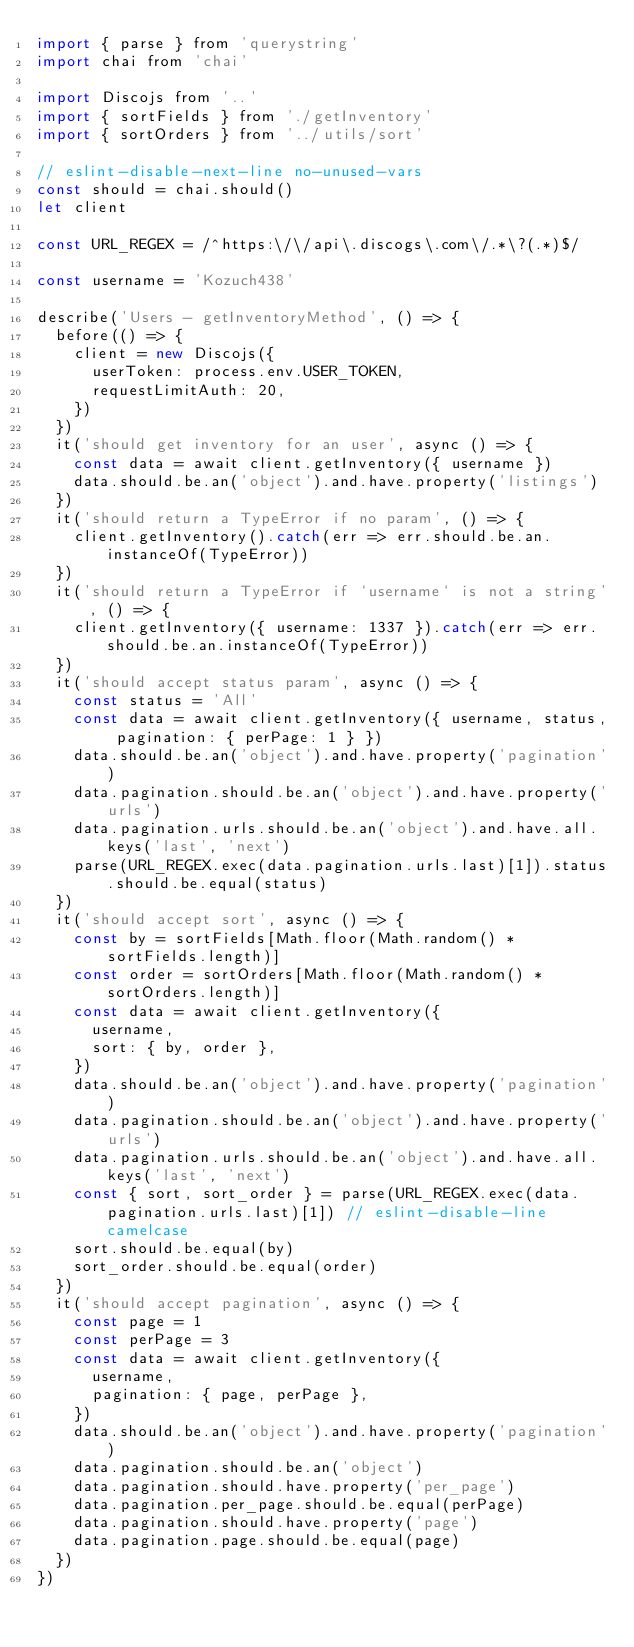Convert code to text. <code><loc_0><loc_0><loc_500><loc_500><_JavaScript_>import { parse } from 'querystring'
import chai from 'chai'

import Discojs from '..'
import { sortFields } from './getInventory'
import { sortOrders } from '../utils/sort'

// eslint-disable-next-line no-unused-vars
const should = chai.should()
let client

const URL_REGEX = /^https:\/\/api\.discogs\.com\/.*\?(.*)$/

const username = 'Kozuch438'

describe('Users - getInventoryMethod', () => {
  before(() => {
    client = new Discojs({
      userToken: process.env.USER_TOKEN,
      requestLimitAuth: 20,
    })
  })
  it('should get inventory for an user', async () => {
    const data = await client.getInventory({ username })
    data.should.be.an('object').and.have.property('listings')
  })
  it('should return a TypeError if no param', () => {
    client.getInventory().catch(err => err.should.be.an.instanceOf(TypeError))
  })
  it('should return a TypeError if `username` is not a string', () => {
    client.getInventory({ username: 1337 }).catch(err => err.should.be.an.instanceOf(TypeError))
  })
  it('should accept status param', async () => {
    const status = 'All'
    const data = await client.getInventory({ username, status, pagination: { perPage: 1 } })
    data.should.be.an('object').and.have.property('pagination')
    data.pagination.should.be.an('object').and.have.property('urls')
    data.pagination.urls.should.be.an('object').and.have.all.keys('last', 'next')
    parse(URL_REGEX.exec(data.pagination.urls.last)[1]).status.should.be.equal(status)
  })
  it('should accept sort', async () => {
    const by = sortFields[Math.floor(Math.random() * sortFields.length)]
    const order = sortOrders[Math.floor(Math.random() * sortOrders.length)]
    const data = await client.getInventory({
      username,
      sort: { by, order },
    })
    data.should.be.an('object').and.have.property('pagination')
    data.pagination.should.be.an('object').and.have.property('urls')
    data.pagination.urls.should.be.an('object').and.have.all.keys('last', 'next')
    const { sort, sort_order } = parse(URL_REGEX.exec(data.pagination.urls.last)[1]) // eslint-disable-line camelcase
    sort.should.be.equal(by)
    sort_order.should.be.equal(order)
  })
  it('should accept pagination', async () => {
    const page = 1
    const perPage = 3
    const data = await client.getInventory({
      username,
      pagination: { page, perPage },
    })
    data.should.be.an('object').and.have.property('pagination')
    data.pagination.should.be.an('object')
    data.pagination.should.have.property('per_page')
    data.pagination.per_page.should.be.equal(perPage)
    data.pagination.should.have.property('page')
    data.pagination.page.should.be.equal(page)
  })
})
</code> 